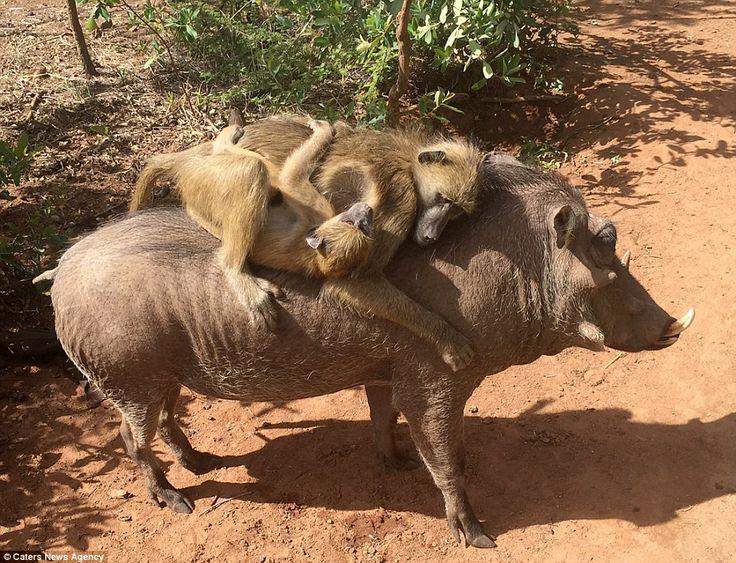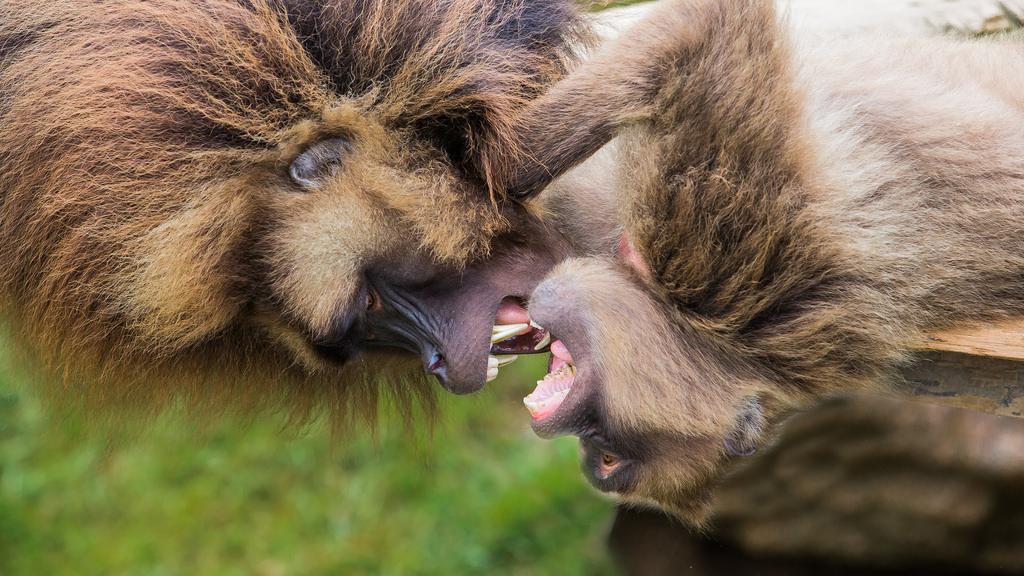The first image is the image on the left, the second image is the image on the right. Considering the images on both sides, is "An image shows two sitting adult monkeys, plus a smaller monkey in the middle of the scene." valid? Answer yes or no. No. 